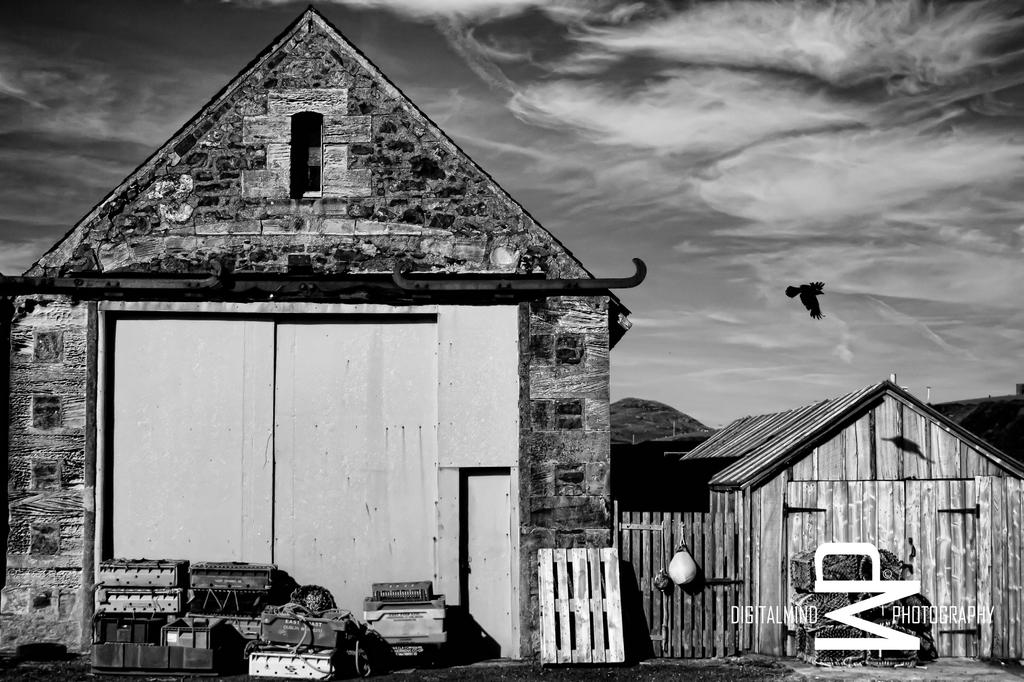What type of structures can be seen in the image? There are houses in the image. What is the material of the fence in the image? The fence in the image is made of wood. What objects are on the path in the image? There are luggages on the path in the image. What is happening in the sky in the image? A bird is flying in the sky in the image, and the sky is cloudy. What type of hobbies can be seen being practiced by the bird in the image? The image does not show any hobbies being practiced by the bird; it is simply flying in the sky. Is there a truck visible in the image? No, there is no truck present in the image. 